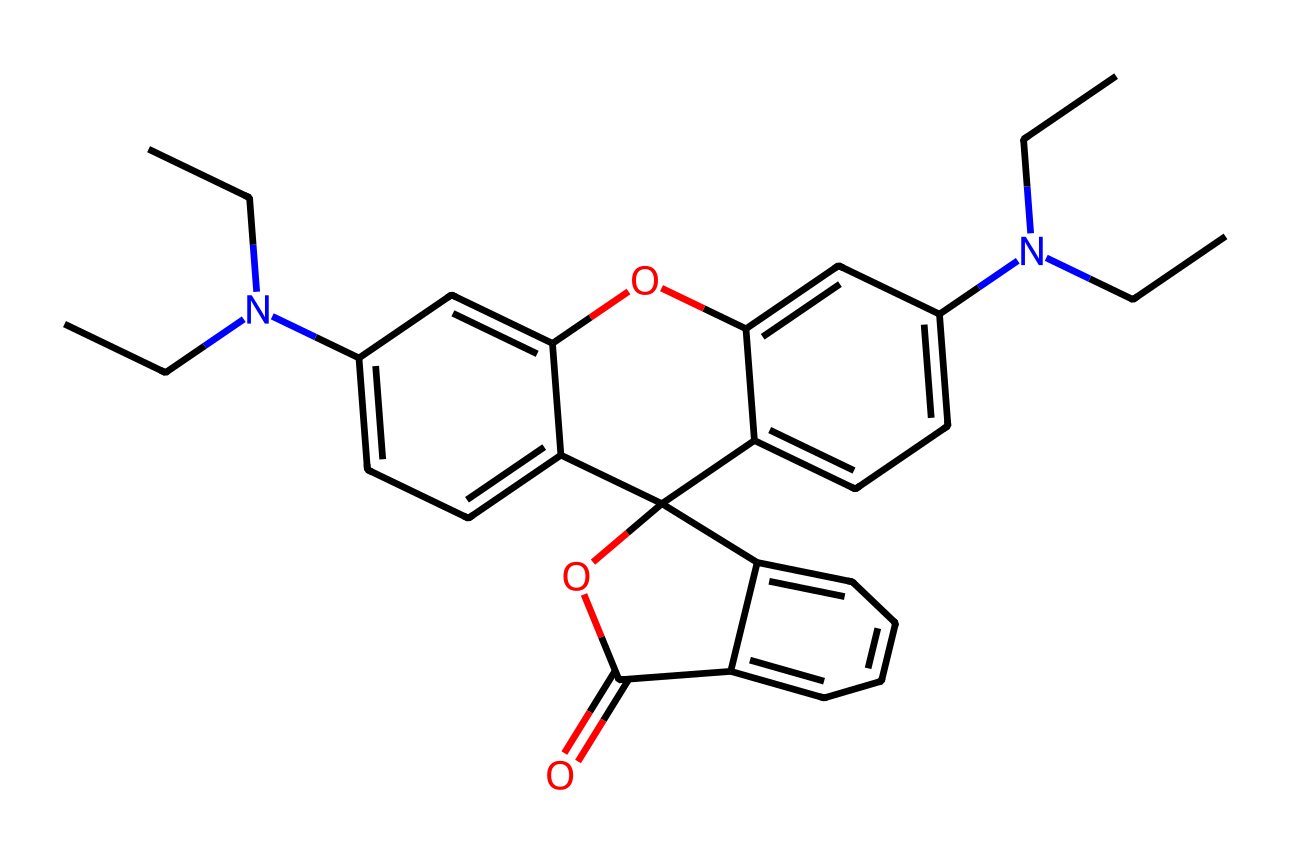What is the primary functional group present in rhodamine B? The chemical structure contains an ester and an amine functional group, but the dominant functional group contributing to dye properties is the phenolic structure associated with the conjugated ring systems.
Answer: phenolic How many nitrogen atoms are present in rhodamine B? By analyzing the SMILES representation, we can identify two nitrogen atoms present in the structure, specifically in the amine groups.
Answer: two What is the total number of rings in the chemical structure of rhodamine B? The structure has a total of three interconnected aromatic rings, which can be visually confirmed by tracing the cyclic parts in the SMILES notation.
Answer: three Which part of rhodamine B contributes to its fluorescence property? The extensive conjugated system made up of the interconnected aromatic rings is the primary contributor to the dye's ability to emit fluorescence upon excitation.
Answer: conjugated system Is rhodamine B classified as an anionic or cationic dye? Analyzing the structure reveals that the presence of the basic nitrogen atoms means rhodamine B can exist as a cationic dye in solution, particularly due to its positively charged amine groups.
Answer: cationic What type of linkage does the chemical structure of rhodamine B contain? The structure comprises an ester linkage part of the attached carboxylic acid and the aromatic rings, observable in the connectivity among functional groups.
Answer: ester linkage What is the molecular formula of rhodamine B? The molecular formula can be deduced from the SMILES notation by counting each type of atom present in the structure, resulting in the formula C28H31N2O3.
Answer: C28H31N2O3 